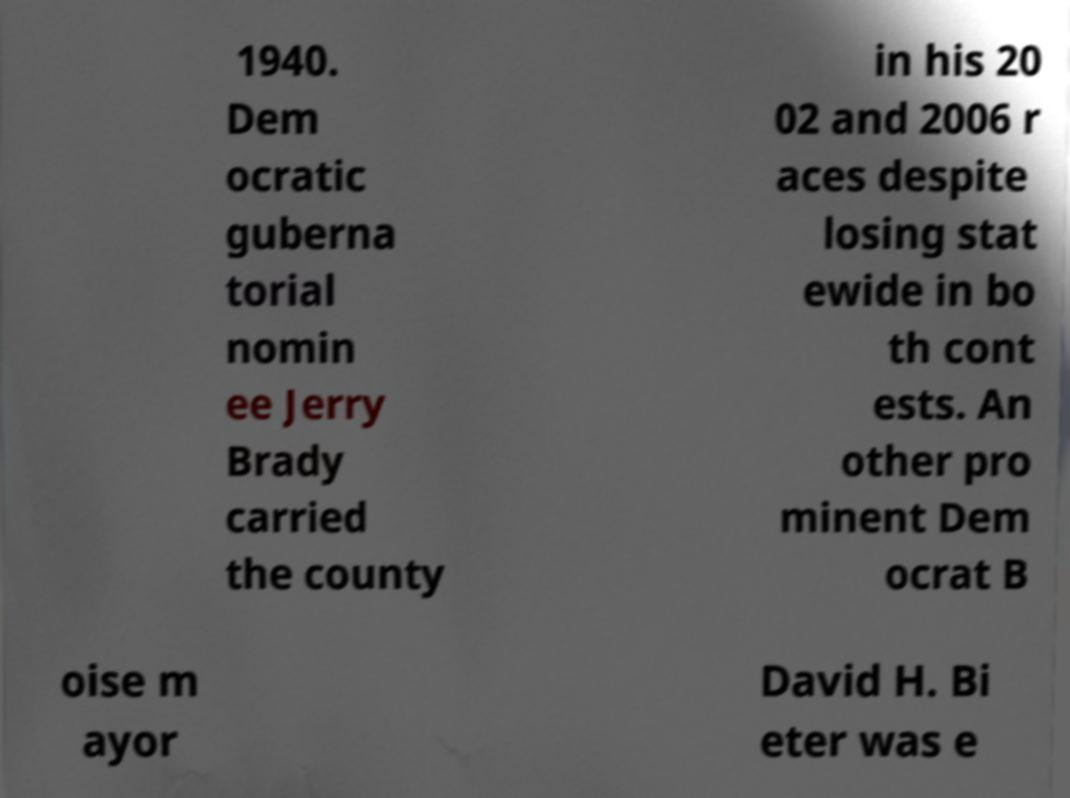There's text embedded in this image that I need extracted. Can you transcribe it verbatim? 1940. Dem ocratic guberna torial nomin ee Jerry Brady carried the county in his 20 02 and 2006 r aces despite losing stat ewide in bo th cont ests. An other pro minent Dem ocrat B oise m ayor David H. Bi eter was e 